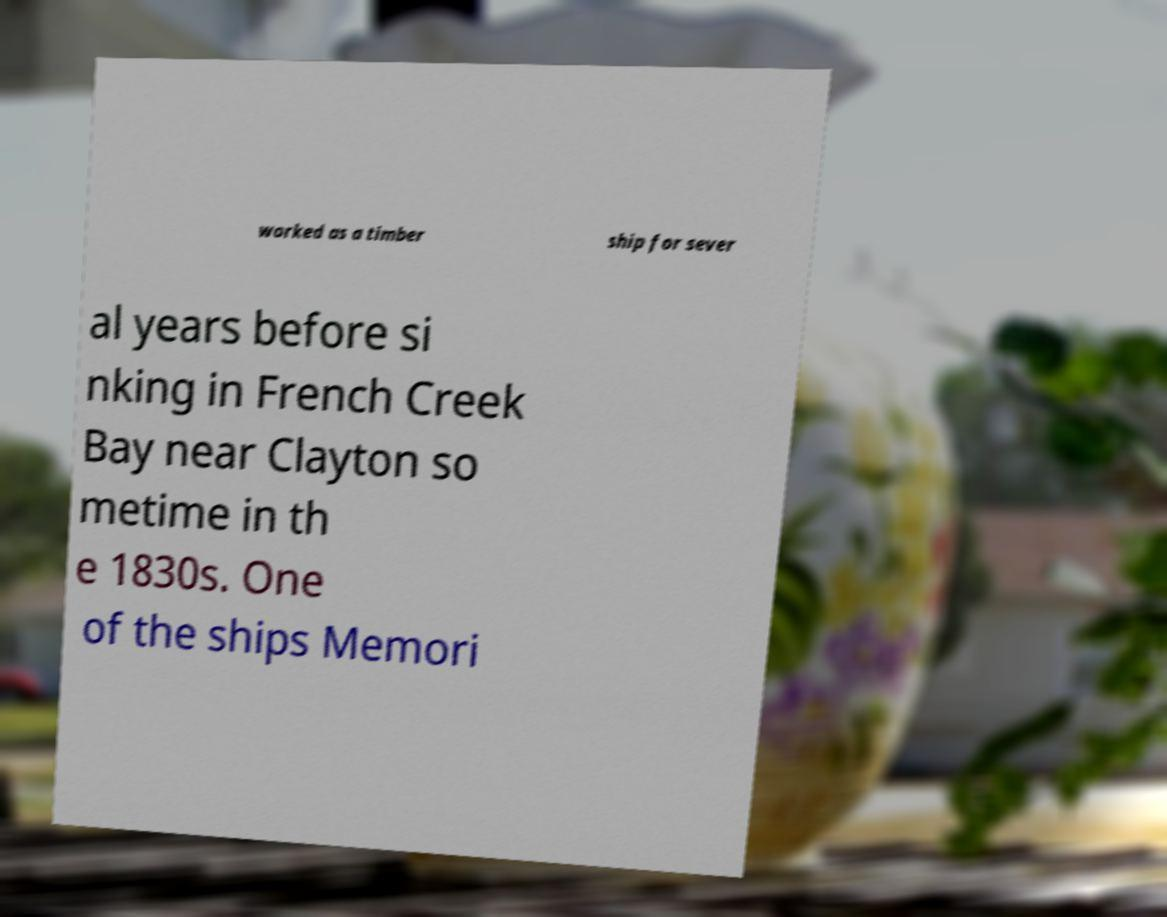For documentation purposes, I need the text within this image transcribed. Could you provide that? worked as a timber ship for sever al years before si nking in French Creek Bay near Clayton so metime in th e 1830s. One of the ships Memori 